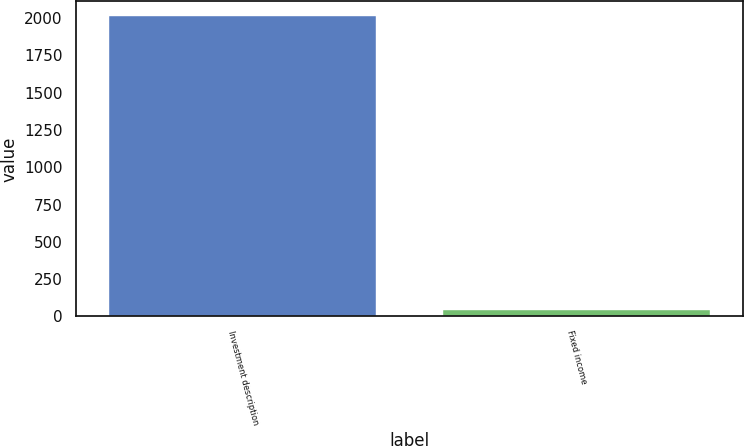<chart> <loc_0><loc_0><loc_500><loc_500><bar_chart><fcel>Investment description<fcel>Fixed income<nl><fcel>2011<fcel>46<nl></chart> 